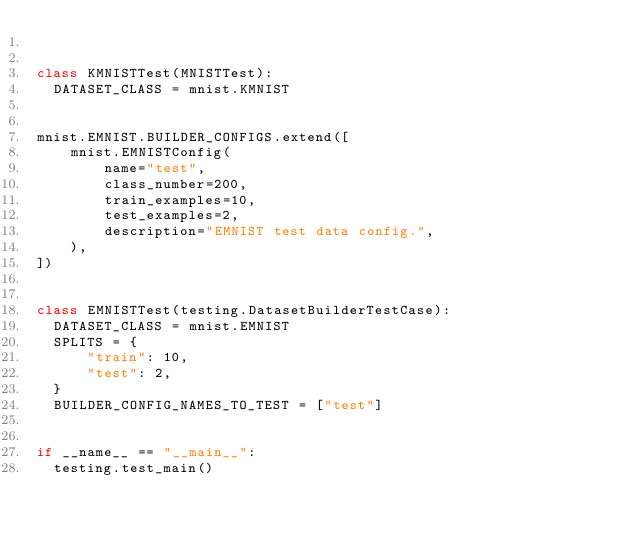Convert code to text. <code><loc_0><loc_0><loc_500><loc_500><_Python_>

class KMNISTTest(MNISTTest):
  DATASET_CLASS = mnist.KMNIST


mnist.EMNIST.BUILDER_CONFIGS.extend([
    mnist.EMNISTConfig(
        name="test",
        class_number=200,
        train_examples=10,
        test_examples=2,
        description="EMNIST test data config.",
    ),
])


class EMNISTTest(testing.DatasetBuilderTestCase):
  DATASET_CLASS = mnist.EMNIST
  SPLITS = {
      "train": 10,
      "test": 2,
  }
  BUILDER_CONFIG_NAMES_TO_TEST = ["test"]


if __name__ == "__main__":
  testing.test_main()
</code> 